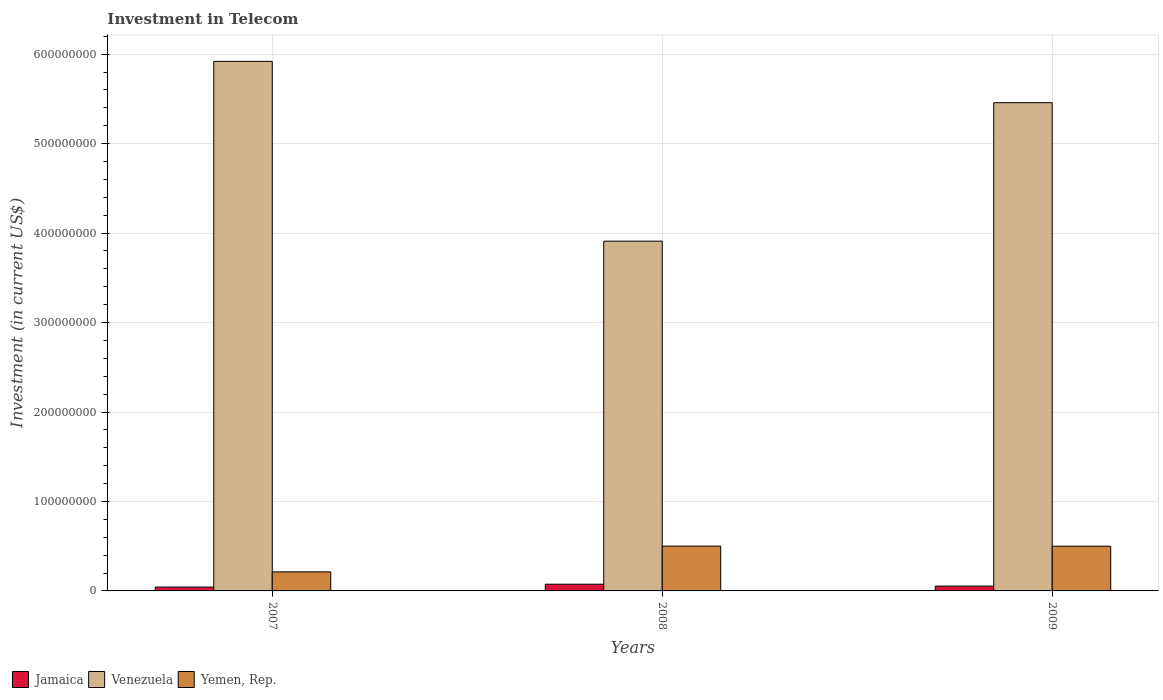How many groups of bars are there?
Give a very brief answer. 3. Are the number of bars on each tick of the X-axis equal?
Provide a short and direct response. Yes. How many bars are there on the 1st tick from the right?
Offer a terse response. 3. What is the label of the 2nd group of bars from the left?
Give a very brief answer. 2008. What is the amount invested in telecom in Jamaica in 2007?
Provide a short and direct response. 4.30e+06. Across all years, what is the maximum amount invested in telecom in Venezuela?
Provide a succinct answer. 5.92e+08. Across all years, what is the minimum amount invested in telecom in Venezuela?
Keep it short and to the point. 3.91e+08. In which year was the amount invested in telecom in Yemen, Rep. maximum?
Provide a short and direct response. 2008. In which year was the amount invested in telecom in Yemen, Rep. minimum?
Your answer should be compact. 2007. What is the total amount invested in telecom in Yemen, Rep. in the graph?
Offer a very short reply. 1.21e+08. What is the difference between the amount invested in telecom in Jamaica in 2007 and that in 2008?
Offer a very short reply. -3.20e+06. What is the difference between the amount invested in telecom in Jamaica in 2007 and the amount invested in telecom in Yemen, Rep. in 2009?
Keep it short and to the point. -4.57e+07. What is the average amount invested in telecom in Yemen, Rep. per year?
Offer a terse response. 4.05e+07. In the year 2009, what is the difference between the amount invested in telecom in Yemen, Rep. and amount invested in telecom in Jamaica?
Make the answer very short. 4.46e+07. In how many years, is the amount invested in telecom in Yemen, Rep. greater than 160000000 US$?
Offer a very short reply. 0. What is the ratio of the amount invested in telecom in Jamaica in 2008 to that in 2009?
Make the answer very short. 1.39. Is the amount invested in telecom in Yemen, Rep. in 2007 less than that in 2008?
Offer a very short reply. Yes. Is the difference between the amount invested in telecom in Yemen, Rep. in 2008 and 2009 greater than the difference between the amount invested in telecom in Jamaica in 2008 and 2009?
Give a very brief answer. No. What is the difference between the highest and the second highest amount invested in telecom in Yemen, Rep.?
Make the answer very short. 1.00e+05. What is the difference between the highest and the lowest amount invested in telecom in Yemen, Rep.?
Ensure brevity in your answer.  2.88e+07. What does the 1st bar from the left in 2007 represents?
Give a very brief answer. Jamaica. What does the 3rd bar from the right in 2007 represents?
Give a very brief answer. Jamaica. How many years are there in the graph?
Your response must be concise. 3. Are the values on the major ticks of Y-axis written in scientific E-notation?
Make the answer very short. No. Does the graph contain any zero values?
Keep it short and to the point. No. Where does the legend appear in the graph?
Offer a terse response. Bottom left. How many legend labels are there?
Offer a very short reply. 3. What is the title of the graph?
Give a very brief answer. Investment in Telecom. Does "Cote d'Ivoire" appear as one of the legend labels in the graph?
Provide a short and direct response. No. What is the label or title of the Y-axis?
Your response must be concise. Investment (in current US$). What is the Investment (in current US$) of Jamaica in 2007?
Keep it short and to the point. 4.30e+06. What is the Investment (in current US$) in Venezuela in 2007?
Make the answer very short. 5.92e+08. What is the Investment (in current US$) in Yemen, Rep. in 2007?
Keep it short and to the point. 2.13e+07. What is the Investment (in current US$) in Jamaica in 2008?
Keep it short and to the point. 7.50e+06. What is the Investment (in current US$) in Venezuela in 2008?
Ensure brevity in your answer.  3.91e+08. What is the Investment (in current US$) of Yemen, Rep. in 2008?
Keep it short and to the point. 5.01e+07. What is the Investment (in current US$) of Jamaica in 2009?
Your answer should be very brief. 5.40e+06. What is the Investment (in current US$) of Venezuela in 2009?
Ensure brevity in your answer.  5.46e+08. What is the Investment (in current US$) of Yemen, Rep. in 2009?
Give a very brief answer. 5.00e+07. Across all years, what is the maximum Investment (in current US$) of Jamaica?
Provide a short and direct response. 7.50e+06. Across all years, what is the maximum Investment (in current US$) of Venezuela?
Offer a very short reply. 5.92e+08. Across all years, what is the maximum Investment (in current US$) in Yemen, Rep.?
Provide a succinct answer. 5.01e+07. Across all years, what is the minimum Investment (in current US$) of Jamaica?
Your response must be concise. 4.30e+06. Across all years, what is the minimum Investment (in current US$) of Venezuela?
Provide a short and direct response. 3.91e+08. Across all years, what is the minimum Investment (in current US$) of Yemen, Rep.?
Give a very brief answer. 2.13e+07. What is the total Investment (in current US$) of Jamaica in the graph?
Offer a very short reply. 1.72e+07. What is the total Investment (in current US$) of Venezuela in the graph?
Provide a short and direct response. 1.53e+09. What is the total Investment (in current US$) in Yemen, Rep. in the graph?
Offer a very short reply. 1.21e+08. What is the difference between the Investment (in current US$) in Jamaica in 2007 and that in 2008?
Your answer should be very brief. -3.20e+06. What is the difference between the Investment (in current US$) in Venezuela in 2007 and that in 2008?
Offer a very short reply. 2.01e+08. What is the difference between the Investment (in current US$) in Yemen, Rep. in 2007 and that in 2008?
Provide a short and direct response. -2.88e+07. What is the difference between the Investment (in current US$) of Jamaica in 2007 and that in 2009?
Give a very brief answer. -1.10e+06. What is the difference between the Investment (in current US$) in Venezuela in 2007 and that in 2009?
Keep it short and to the point. 4.62e+07. What is the difference between the Investment (in current US$) of Yemen, Rep. in 2007 and that in 2009?
Your answer should be compact. -2.87e+07. What is the difference between the Investment (in current US$) in Jamaica in 2008 and that in 2009?
Ensure brevity in your answer.  2.10e+06. What is the difference between the Investment (in current US$) of Venezuela in 2008 and that in 2009?
Your response must be concise. -1.55e+08. What is the difference between the Investment (in current US$) of Jamaica in 2007 and the Investment (in current US$) of Venezuela in 2008?
Ensure brevity in your answer.  -3.87e+08. What is the difference between the Investment (in current US$) in Jamaica in 2007 and the Investment (in current US$) in Yemen, Rep. in 2008?
Provide a short and direct response. -4.58e+07. What is the difference between the Investment (in current US$) in Venezuela in 2007 and the Investment (in current US$) in Yemen, Rep. in 2008?
Your answer should be very brief. 5.42e+08. What is the difference between the Investment (in current US$) in Jamaica in 2007 and the Investment (in current US$) in Venezuela in 2009?
Keep it short and to the point. -5.42e+08. What is the difference between the Investment (in current US$) of Jamaica in 2007 and the Investment (in current US$) of Yemen, Rep. in 2009?
Ensure brevity in your answer.  -4.57e+07. What is the difference between the Investment (in current US$) in Venezuela in 2007 and the Investment (in current US$) in Yemen, Rep. in 2009?
Give a very brief answer. 5.42e+08. What is the difference between the Investment (in current US$) in Jamaica in 2008 and the Investment (in current US$) in Venezuela in 2009?
Give a very brief answer. -5.38e+08. What is the difference between the Investment (in current US$) of Jamaica in 2008 and the Investment (in current US$) of Yemen, Rep. in 2009?
Keep it short and to the point. -4.25e+07. What is the difference between the Investment (in current US$) of Venezuela in 2008 and the Investment (in current US$) of Yemen, Rep. in 2009?
Your answer should be compact. 3.41e+08. What is the average Investment (in current US$) of Jamaica per year?
Ensure brevity in your answer.  5.73e+06. What is the average Investment (in current US$) in Venezuela per year?
Offer a very short reply. 5.10e+08. What is the average Investment (in current US$) in Yemen, Rep. per year?
Provide a short and direct response. 4.05e+07. In the year 2007, what is the difference between the Investment (in current US$) in Jamaica and Investment (in current US$) in Venezuela?
Give a very brief answer. -5.88e+08. In the year 2007, what is the difference between the Investment (in current US$) of Jamaica and Investment (in current US$) of Yemen, Rep.?
Your answer should be very brief. -1.70e+07. In the year 2007, what is the difference between the Investment (in current US$) in Venezuela and Investment (in current US$) in Yemen, Rep.?
Give a very brief answer. 5.71e+08. In the year 2008, what is the difference between the Investment (in current US$) in Jamaica and Investment (in current US$) in Venezuela?
Provide a succinct answer. -3.84e+08. In the year 2008, what is the difference between the Investment (in current US$) of Jamaica and Investment (in current US$) of Yemen, Rep.?
Keep it short and to the point. -4.26e+07. In the year 2008, what is the difference between the Investment (in current US$) in Venezuela and Investment (in current US$) in Yemen, Rep.?
Make the answer very short. 3.41e+08. In the year 2009, what is the difference between the Investment (in current US$) of Jamaica and Investment (in current US$) of Venezuela?
Keep it short and to the point. -5.40e+08. In the year 2009, what is the difference between the Investment (in current US$) in Jamaica and Investment (in current US$) in Yemen, Rep.?
Make the answer very short. -4.46e+07. In the year 2009, what is the difference between the Investment (in current US$) in Venezuela and Investment (in current US$) in Yemen, Rep.?
Provide a short and direct response. 4.96e+08. What is the ratio of the Investment (in current US$) of Jamaica in 2007 to that in 2008?
Your response must be concise. 0.57. What is the ratio of the Investment (in current US$) of Venezuela in 2007 to that in 2008?
Provide a succinct answer. 1.51. What is the ratio of the Investment (in current US$) in Yemen, Rep. in 2007 to that in 2008?
Keep it short and to the point. 0.43. What is the ratio of the Investment (in current US$) of Jamaica in 2007 to that in 2009?
Ensure brevity in your answer.  0.8. What is the ratio of the Investment (in current US$) of Venezuela in 2007 to that in 2009?
Give a very brief answer. 1.08. What is the ratio of the Investment (in current US$) in Yemen, Rep. in 2007 to that in 2009?
Make the answer very short. 0.43. What is the ratio of the Investment (in current US$) in Jamaica in 2008 to that in 2009?
Your answer should be very brief. 1.39. What is the ratio of the Investment (in current US$) in Venezuela in 2008 to that in 2009?
Your answer should be compact. 0.72. What is the ratio of the Investment (in current US$) of Yemen, Rep. in 2008 to that in 2009?
Your answer should be compact. 1. What is the difference between the highest and the second highest Investment (in current US$) of Jamaica?
Keep it short and to the point. 2.10e+06. What is the difference between the highest and the second highest Investment (in current US$) of Venezuela?
Offer a terse response. 4.62e+07. What is the difference between the highest and the second highest Investment (in current US$) of Yemen, Rep.?
Make the answer very short. 1.00e+05. What is the difference between the highest and the lowest Investment (in current US$) in Jamaica?
Keep it short and to the point. 3.20e+06. What is the difference between the highest and the lowest Investment (in current US$) of Venezuela?
Provide a succinct answer. 2.01e+08. What is the difference between the highest and the lowest Investment (in current US$) in Yemen, Rep.?
Provide a short and direct response. 2.88e+07. 